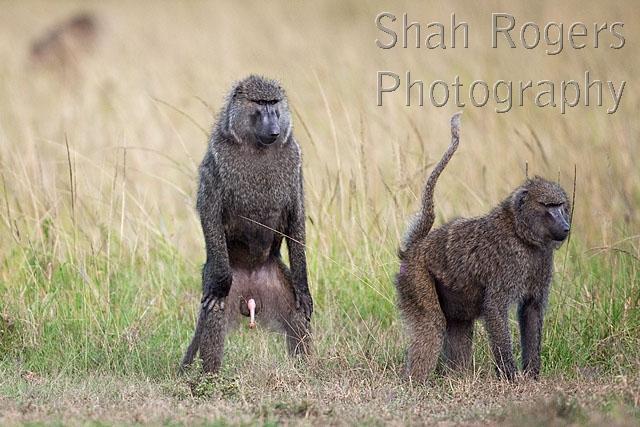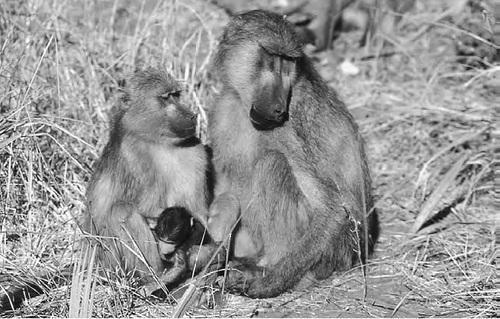The first image is the image on the left, the second image is the image on the right. Given the left and right images, does the statement "The right image features two adult baboons stting with a small baby baboon." hold true? Answer yes or no. Yes. 